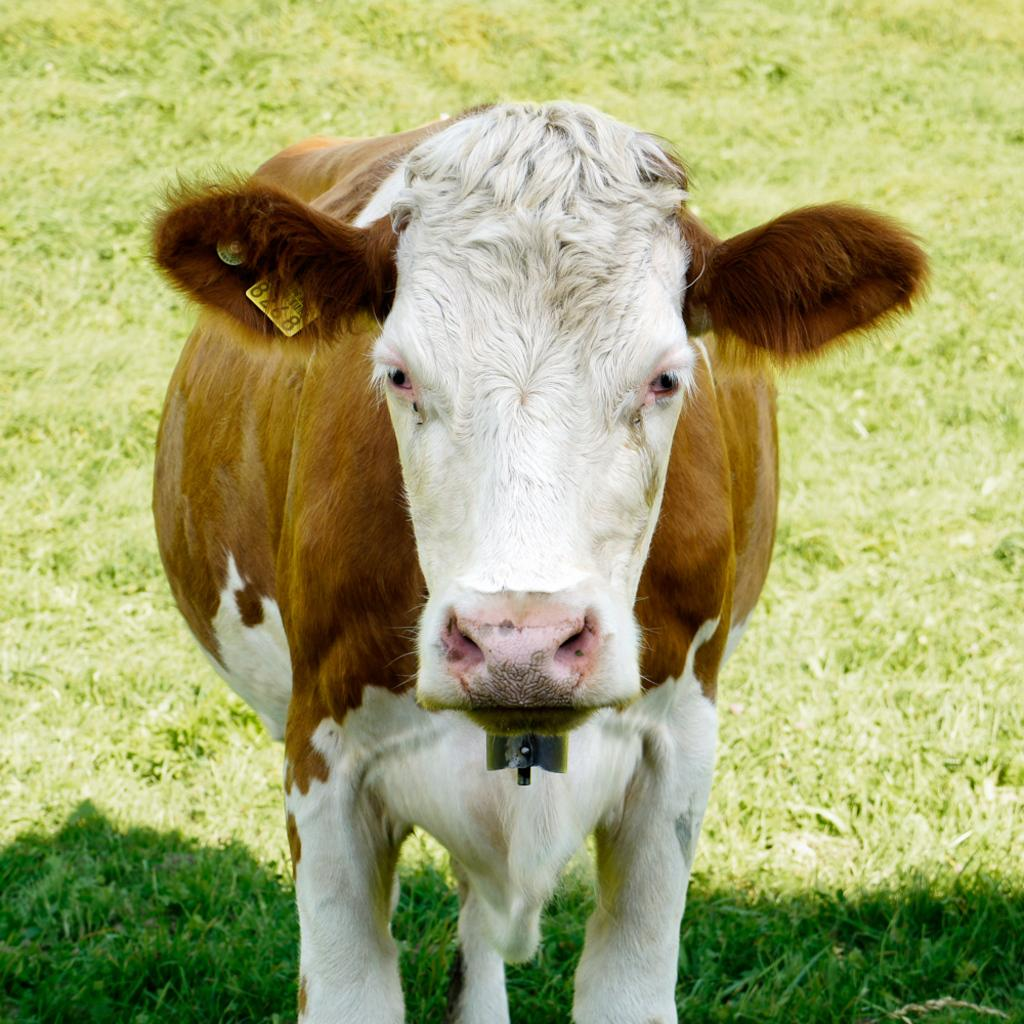What is attached to the animal in the image? There is a tag on an animal in the image. What type of surface is visible in the background? The ground in the background is covered with grass. How many girls are present in the image? There is no mention of girls in the provided facts, so we cannot determine their presence in the image. What type of bird can be seen in the image? There is no bird mentioned in the provided facts, so we cannot determine its presence in the image. 